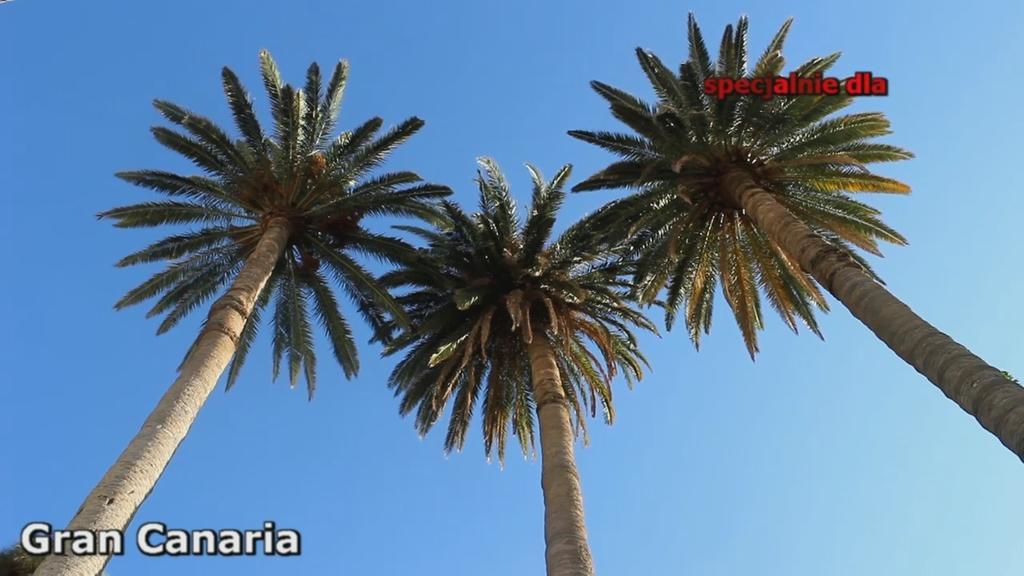Describe this image in one or two sentences. In the image there are three coconut trees in the front and above its sky. 